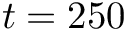Convert formula to latex. <formula><loc_0><loc_0><loc_500><loc_500>t = 2 5 0</formula> 